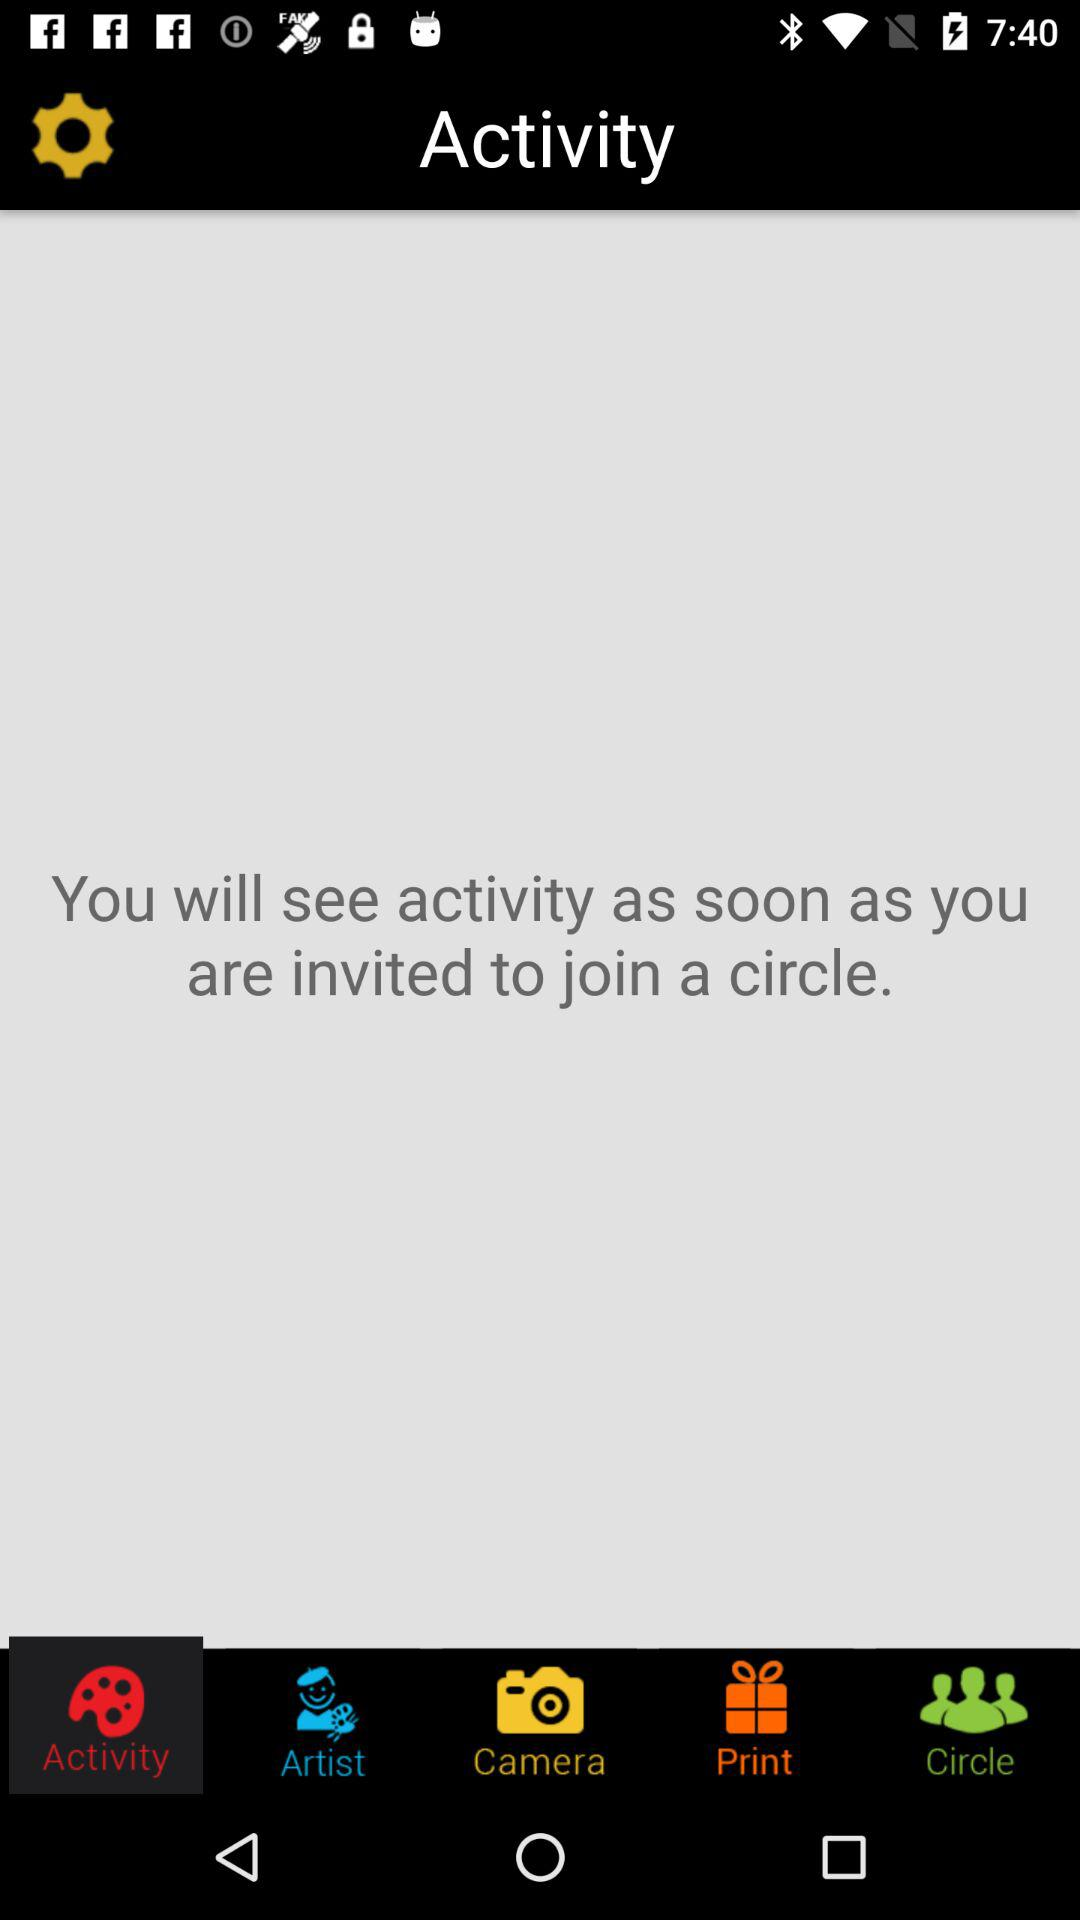Which tab is selected? The selected tab is "Activity". 